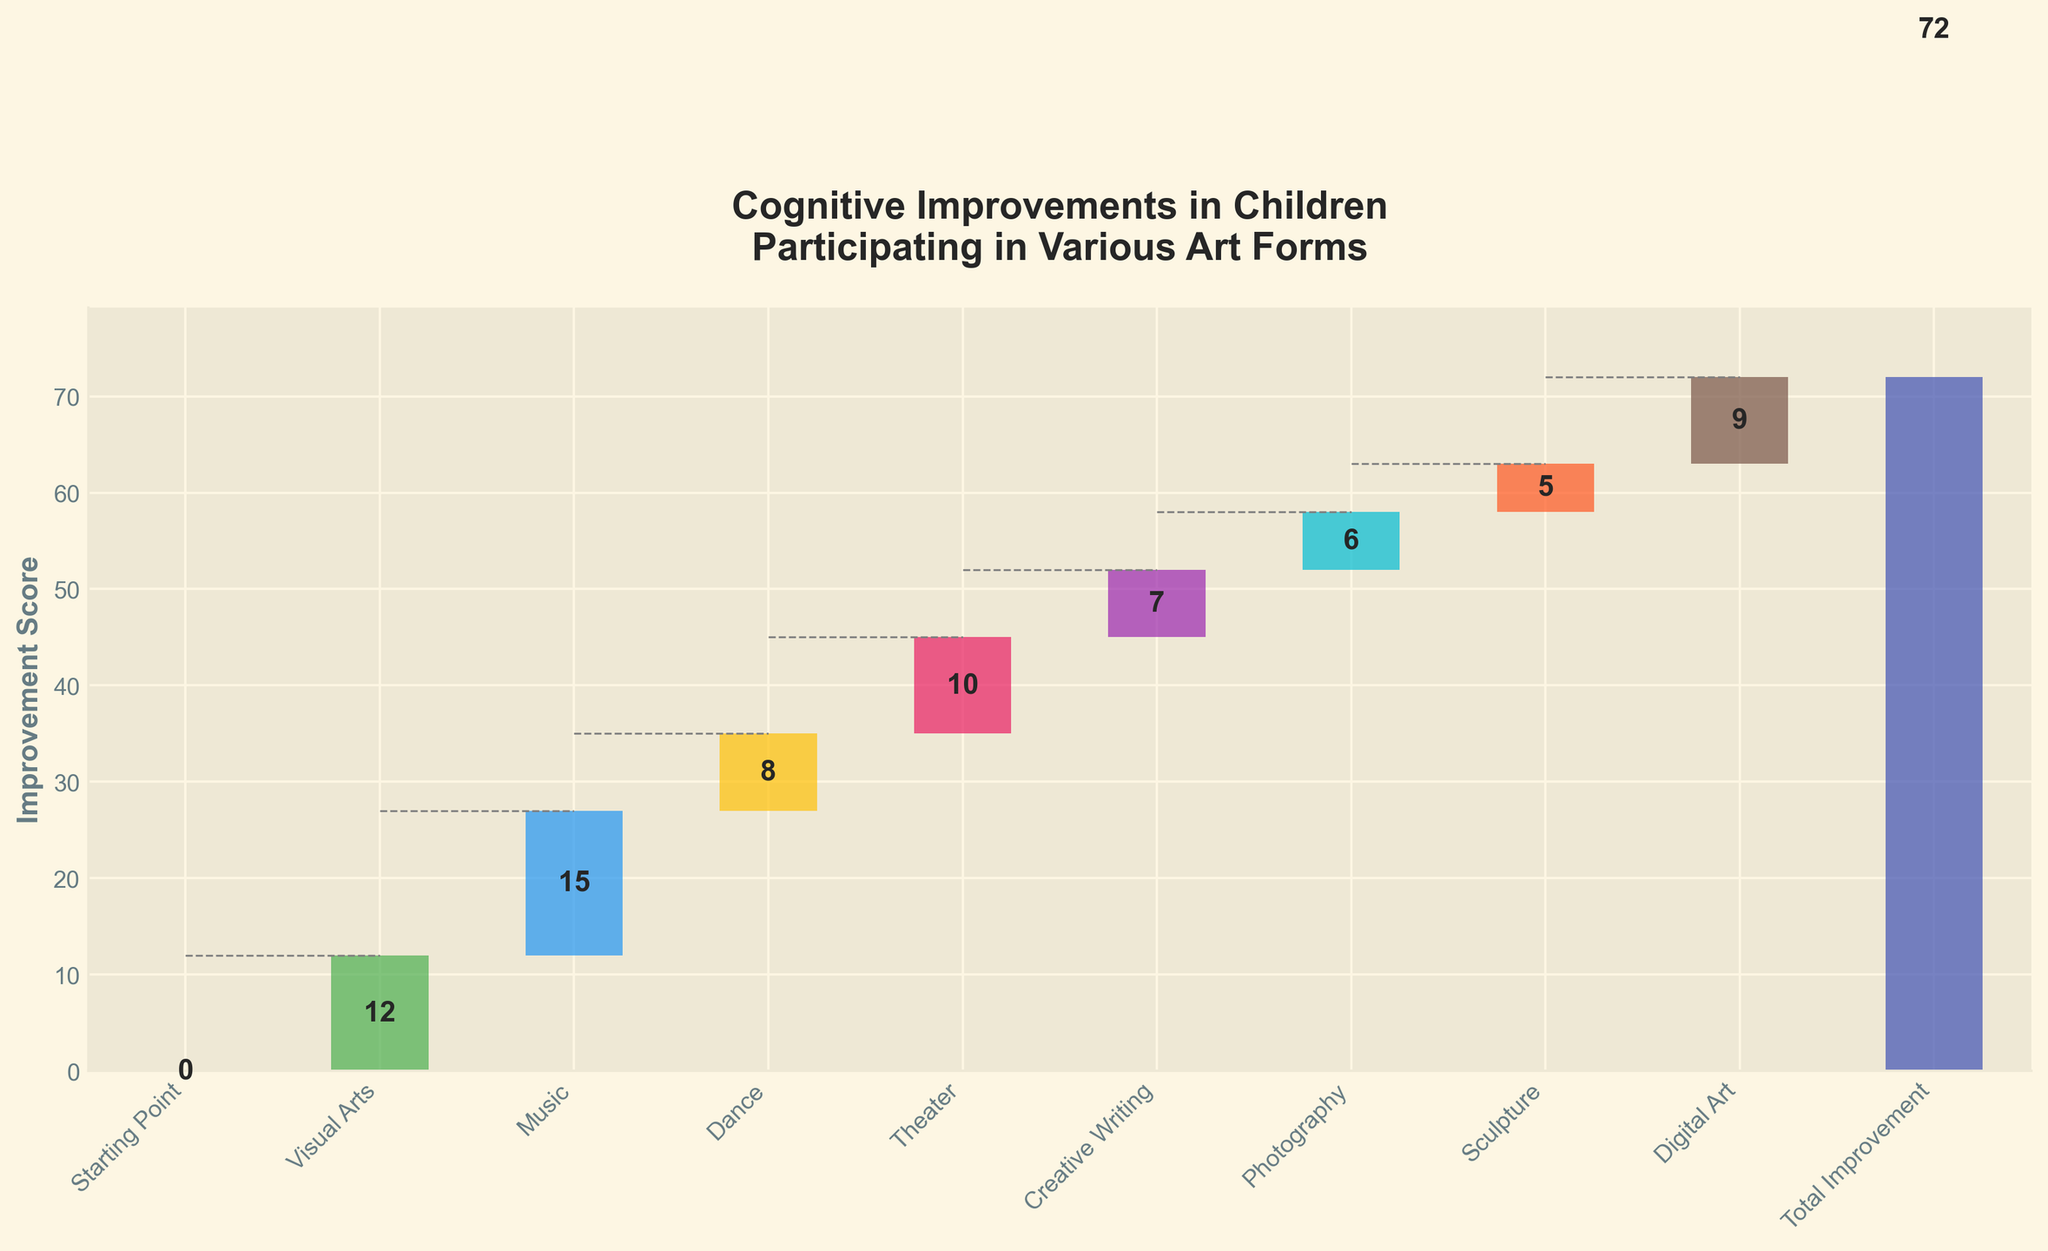What is the title of the chart? The title is located at the top center of the chart. It provides an overview of what the chart depicts.
Answer: Cognitive Improvements in Children Participating in Various Art Forms Which art form contributed the most to cognitive improvement? By looking at the individual contribution values, we identify the highest one.
Answer: Music (15) What is the combined total improvement from Visual Arts, Music, and Dance? The values for these art forms are 12 (Visual Arts), 15 (Music), and 8 (Dance). Adding them up gives 12 + 15 + 8 = 35.
Answer: 35 How does the improvement from Theater compare to that from Creative Writing? By comparing the values for Theater (10) and Creative Writing (7), we can see that Theater has a higher value.
Answer: Theater (10) is higher What is the overall trend seen in the contributions from all art forms? By observing the cumulative bars, we can see how each art form incrementally adds up to reach the total improvement value at the end.
Answer: Increasing What's the smallest improvement score among all the art forms? To find the smallest score, look at the individual increments and identify the lowest value.
Answer: Sculpture (5) If we exclude Digital Art, what is the new total improvement value? The original total improvement is 72. Subtract the value for Digital Art (9) from this total: 72 - 9 = 63.
Answer: 63 Compare the improvement from Photography to Theater. Which one is higher and by how much? Photography has a value of 6, and Theater has 10. The difference is 10 - 6 = 4.
Answer: Theater is higher by 4 What’s the cumulative improvement after including the contributions from Visual Arts and Music? The values are 12 (Visual Arts) and 15 (Music). So, the cumulative improvement after these two will be 12 + 15 = 27.
Answer: 27 How many art forms have a contribution of 10 or more? Look at the contributions and count how many are 10 or larger: Theater (10), Music (15), Visual Arts (12).
Answer: 3 